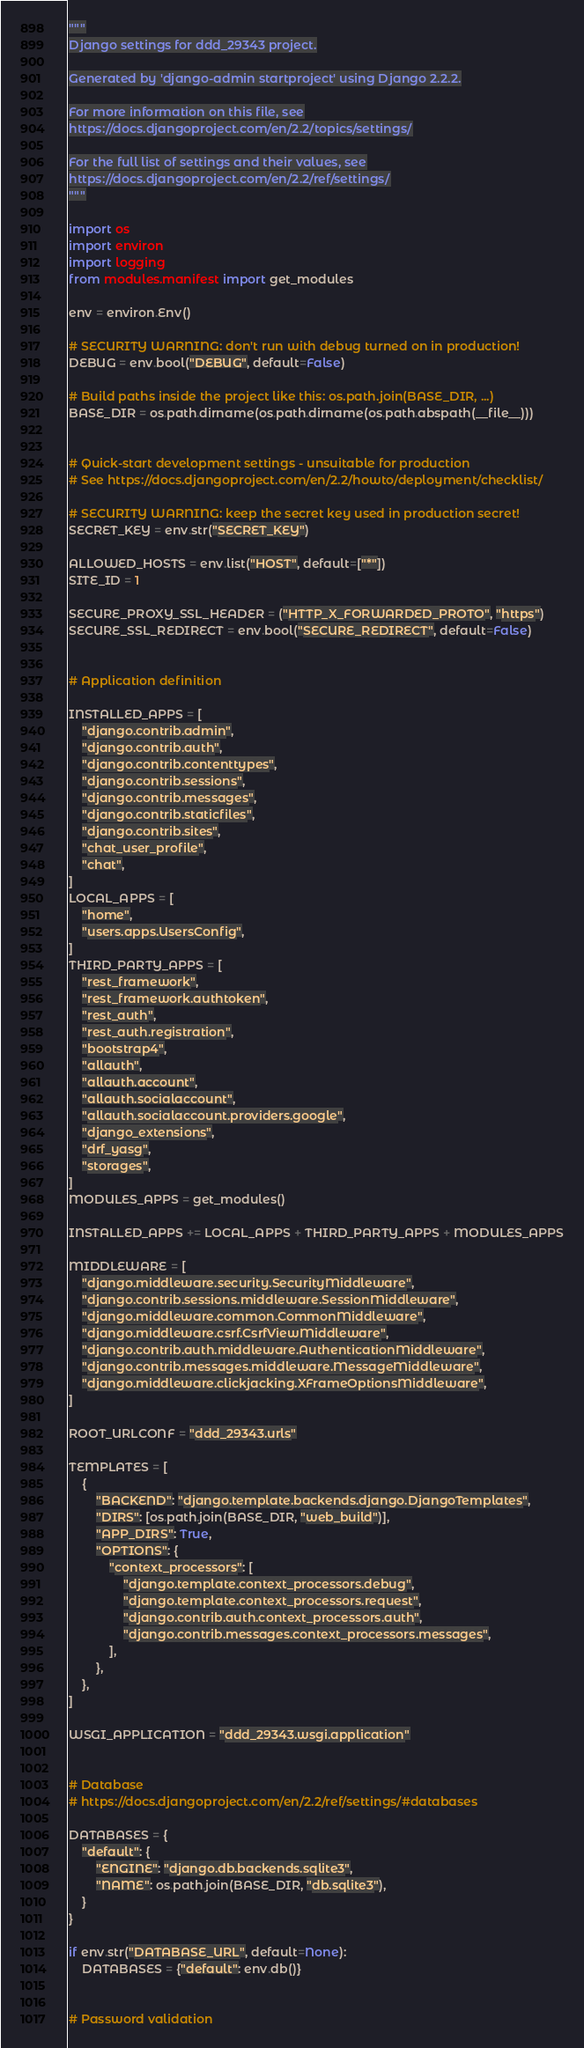<code> <loc_0><loc_0><loc_500><loc_500><_Python_>"""
Django settings for ddd_29343 project.

Generated by 'django-admin startproject' using Django 2.2.2.

For more information on this file, see
https://docs.djangoproject.com/en/2.2/topics/settings/

For the full list of settings and their values, see
https://docs.djangoproject.com/en/2.2/ref/settings/
"""

import os
import environ
import logging
from modules.manifest import get_modules

env = environ.Env()

# SECURITY WARNING: don't run with debug turned on in production!
DEBUG = env.bool("DEBUG", default=False)

# Build paths inside the project like this: os.path.join(BASE_DIR, ...)
BASE_DIR = os.path.dirname(os.path.dirname(os.path.abspath(__file__)))


# Quick-start development settings - unsuitable for production
# See https://docs.djangoproject.com/en/2.2/howto/deployment/checklist/

# SECURITY WARNING: keep the secret key used in production secret!
SECRET_KEY = env.str("SECRET_KEY")

ALLOWED_HOSTS = env.list("HOST", default=["*"])
SITE_ID = 1

SECURE_PROXY_SSL_HEADER = ("HTTP_X_FORWARDED_PROTO", "https")
SECURE_SSL_REDIRECT = env.bool("SECURE_REDIRECT", default=False)


# Application definition

INSTALLED_APPS = [
    "django.contrib.admin",
    "django.contrib.auth",
    "django.contrib.contenttypes",
    "django.contrib.sessions",
    "django.contrib.messages",
    "django.contrib.staticfiles",
    "django.contrib.sites",
    "chat_user_profile",
    "chat",
]
LOCAL_APPS = [
    "home",
    "users.apps.UsersConfig",
]
THIRD_PARTY_APPS = [
    "rest_framework",
    "rest_framework.authtoken",
    "rest_auth",
    "rest_auth.registration",
    "bootstrap4",
    "allauth",
    "allauth.account",
    "allauth.socialaccount",
    "allauth.socialaccount.providers.google",
    "django_extensions",
    "drf_yasg",
    "storages",
]
MODULES_APPS = get_modules()

INSTALLED_APPS += LOCAL_APPS + THIRD_PARTY_APPS + MODULES_APPS

MIDDLEWARE = [
    "django.middleware.security.SecurityMiddleware",
    "django.contrib.sessions.middleware.SessionMiddleware",
    "django.middleware.common.CommonMiddleware",
    "django.middleware.csrf.CsrfViewMiddleware",
    "django.contrib.auth.middleware.AuthenticationMiddleware",
    "django.contrib.messages.middleware.MessageMiddleware",
    "django.middleware.clickjacking.XFrameOptionsMiddleware",
]

ROOT_URLCONF = "ddd_29343.urls"

TEMPLATES = [
    {
        "BACKEND": "django.template.backends.django.DjangoTemplates",
        "DIRS": [os.path.join(BASE_DIR, "web_build")],
        "APP_DIRS": True,
        "OPTIONS": {
            "context_processors": [
                "django.template.context_processors.debug",
                "django.template.context_processors.request",
                "django.contrib.auth.context_processors.auth",
                "django.contrib.messages.context_processors.messages",
            ],
        },
    },
]

WSGI_APPLICATION = "ddd_29343.wsgi.application"


# Database
# https://docs.djangoproject.com/en/2.2/ref/settings/#databases

DATABASES = {
    "default": {
        "ENGINE": "django.db.backends.sqlite3",
        "NAME": os.path.join(BASE_DIR, "db.sqlite3"),
    }
}

if env.str("DATABASE_URL", default=None):
    DATABASES = {"default": env.db()}


# Password validation</code> 